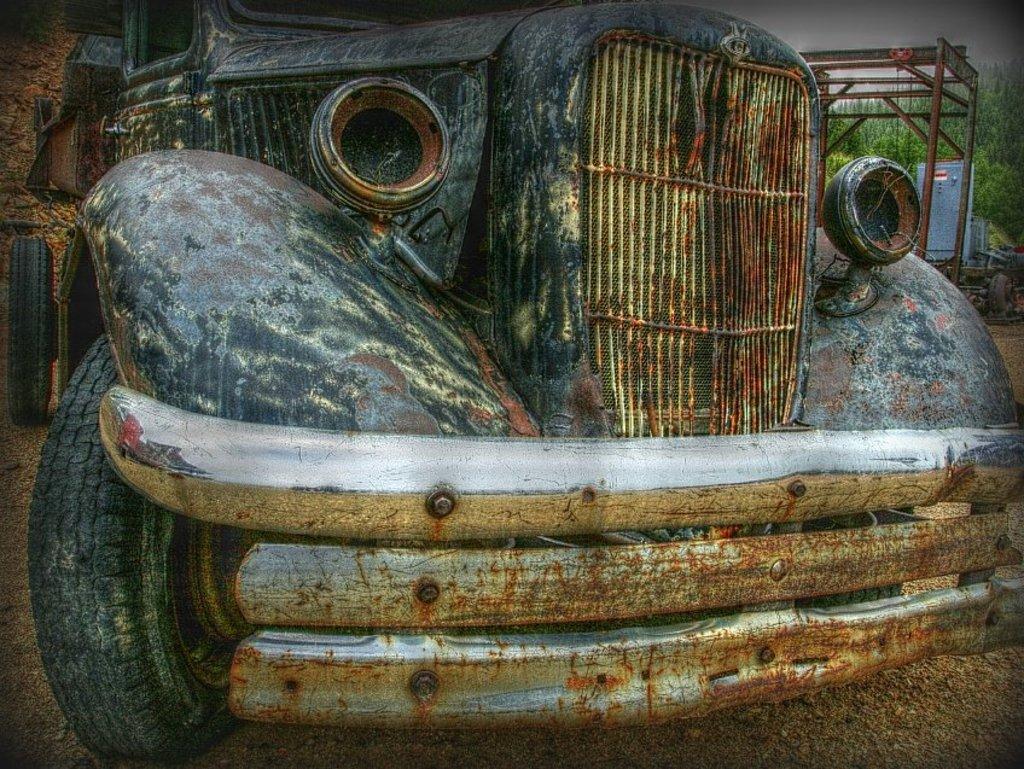Describe this image in one or two sentences. In this image we can see a vehicle. We can see some reflection on a vehicle at the left side of the image. There are few object at the right side of the image. There are many trees in the image. 